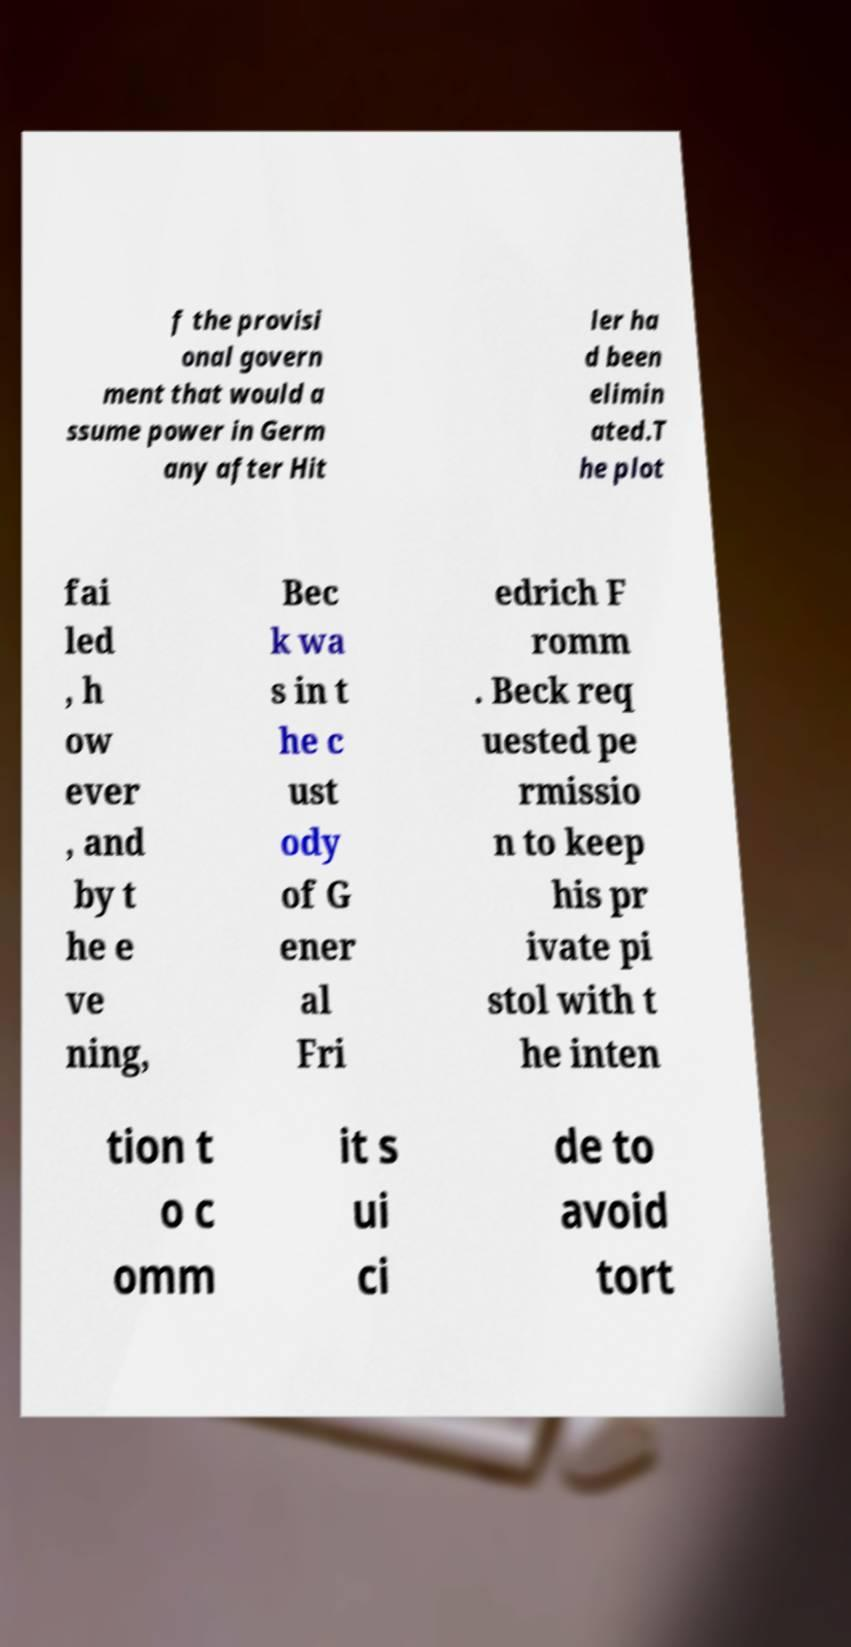Could you extract and type out the text from this image? f the provisi onal govern ment that would a ssume power in Germ any after Hit ler ha d been elimin ated.T he plot fai led , h ow ever , and by t he e ve ning, Bec k wa s in t he c ust ody of G ener al Fri edrich F romm . Beck req uested pe rmissio n to keep his pr ivate pi stol with t he inten tion t o c omm it s ui ci de to avoid tort 